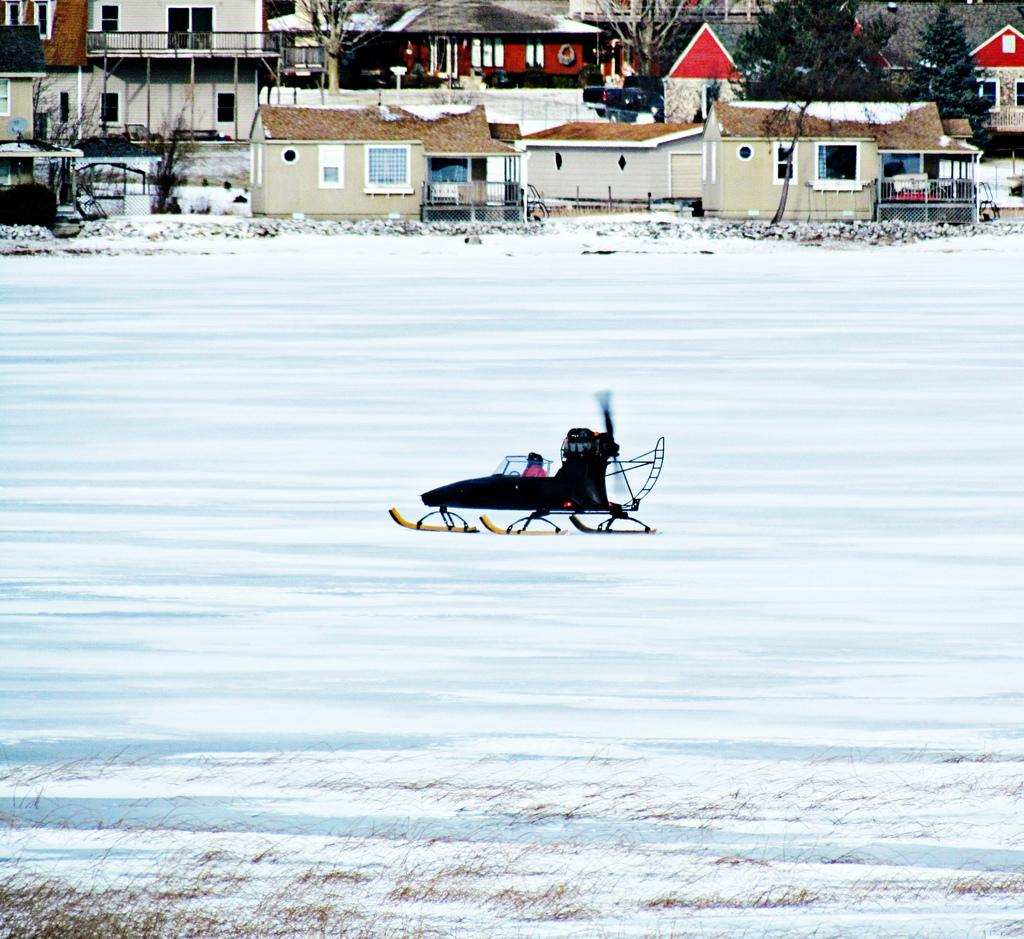What is the main feature in the center of the image? There is snow and roller skates in the center of the image. What can be seen at the top side of the image? There are houses and trees at the top side of the image. How many knives are visible in the image? There are no knives present in the image. What time of day is depicted in the image? The provided facts do not mention the time of day, so it cannot be determined from the image. 